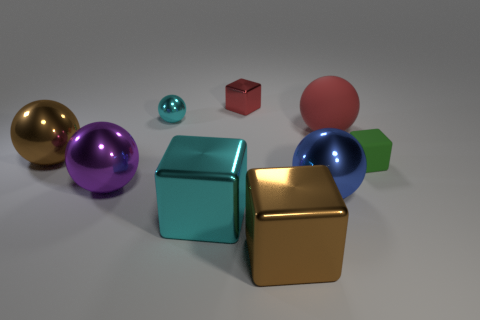How many objects are metallic objects that are behind the brown metallic block or balls behind the small matte object?
Provide a short and direct response. 7. Is the color of the rubber cube the same as the small shiny block?
Give a very brief answer. No. There is a tiny block that is the same color as the large rubber object; what is its material?
Your response must be concise. Metal. Are there fewer blue metallic objects in front of the blue shiny object than big objects right of the purple shiny ball?
Provide a succinct answer. Yes. Does the big brown sphere have the same material as the purple object?
Offer a terse response. Yes. There is a cube that is in front of the big blue thing and on the right side of the cyan cube; what is its size?
Ensure brevity in your answer.  Large. There is a red metal thing that is the same size as the green thing; what is its shape?
Your response must be concise. Cube. What material is the large object that is behind the brown metallic object on the left side of the large brown shiny object that is on the right side of the brown sphere?
Your answer should be compact. Rubber. Does the cyan thing in front of the large red rubber sphere have the same shape as the cyan thing that is behind the rubber sphere?
Offer a very short reply. No. How many other things are there of the same material as the cyan cube?
Provide a succinct answer. 6. 